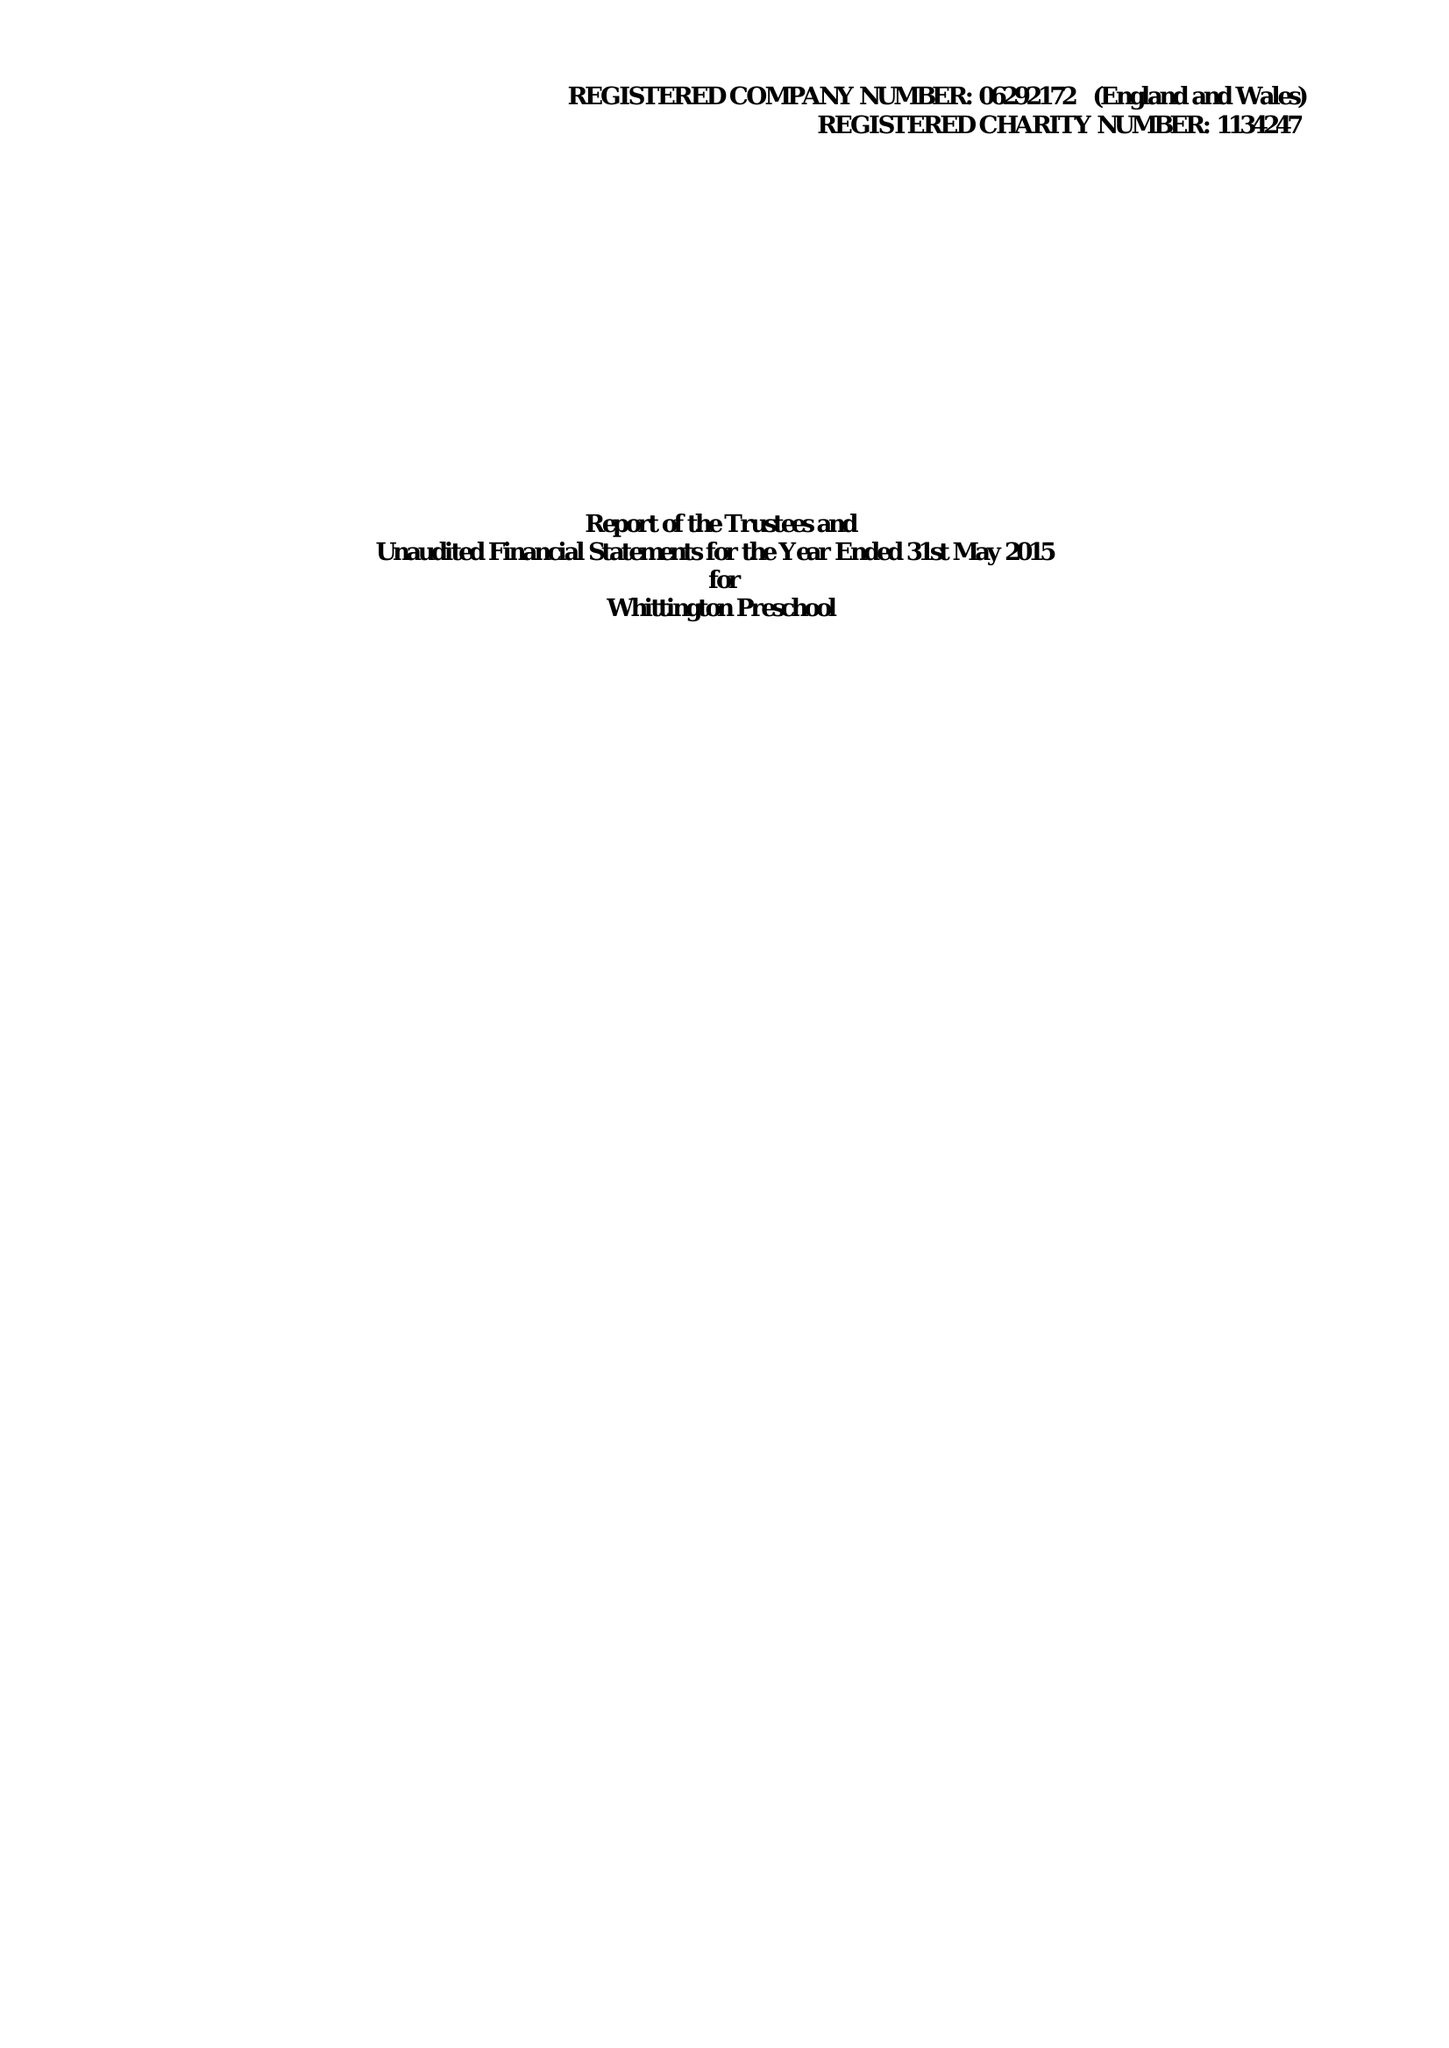What is the value for the income_annually_in_british_pounds?
Answer the question using a single word or phrase. 255155.00 